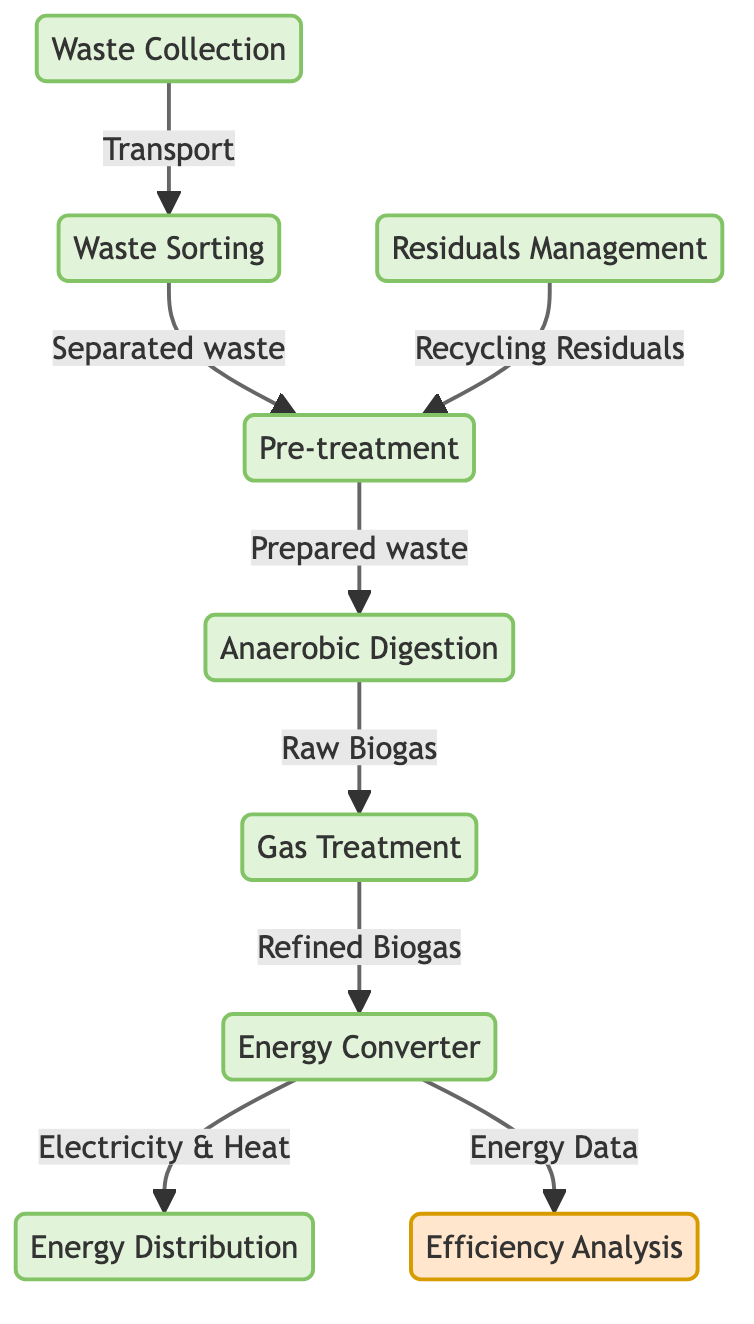What is the first step in the waste-to-energy process? The first step is represented by the node "Waste Collection." It indicates that waste must first be collected before any further processing can take place.
Answer: Waste Collection How many main processes are involved in the waste-to-energy workflow? The diagram features eight distinct processes: Waste Collection, Waste Sorting, Pre-treatment, Anaerobic Digestion, Gas Treatment, Energy Converter, Energy Distribution, and Residuals Management. Therefore, counting all the processes gives us a total of eight.
Answer: Eight Which process directly receives output from Anaerobic Digestion? The output labeled "Raw Biogas" from Anaerobic Digestion flows into the next process, which is Gas Treatment. This indicates that Gas Treatment is the process that handles the output directly after Anaerobic Digestion.
Answer: Gas Treatment What type of data is generated by the Energy Converter? The Energy Converter produces two types of energy, namely "Electricity & Heat." This is explicitly stated in the diagram as the output of the Energy Converter process.
Answer: Electricity & Heat What is the relationship between Energy Distribution and Efficiency Analysis? The Energy Distribution process outputs "Energy Data" to the Efficiency Analysis. This illustrates that the energy data generated is evaluated in the analysis to possibly assess the system’s operational effectiveness.
Answer: Energy Data What role does Residuals Management play in relation to Pre-treatment? Residuals Management outputs "Recycling Residuals" back to the Pre-treatment process. This indicates that any residuals collected are recycled and potentially reused in the Pre-treatment stage, ensuring a closed-loop system.
Answer: Recycling Residuals 